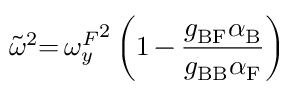Convert formula to latex. <formula><loc_0><loc_0><loc_500><loc_500>\tilde { \omega } ^ { 2 } { = } \, { \omega _ { y } ^ { F } } ^ { 2 } \left ( 1 \, { - } \, \frac { g _ { B F } \alpha _ { B } } { g _ { B B } \alpha _ { F } } \right )</formula> 